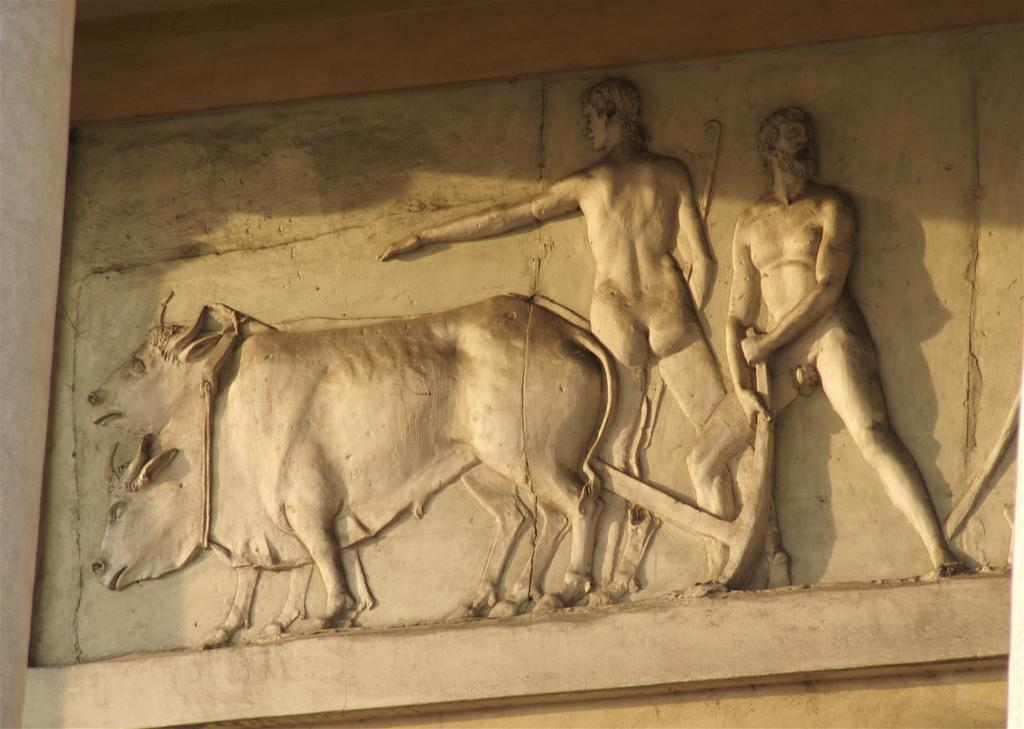What is depicted on the stone in the image? There are carvings on a stone in the image. Where is the stone located? The stone is on a wall. How many people are in the image? There are two persons in the image. What are the persons doing in the image? The persons are cultivating the land and using cows to help with cultivation. Can you see a beetle crawling on the edge of the stone in the image? There is no beetle or edge of the stone mentioned in the image; it only describes carvings on a stone and its location on a wall. Are there any horses present in the image? No, there are no horses mentioned in the image; it only describes two persons cultivating the land with the help of cows. 